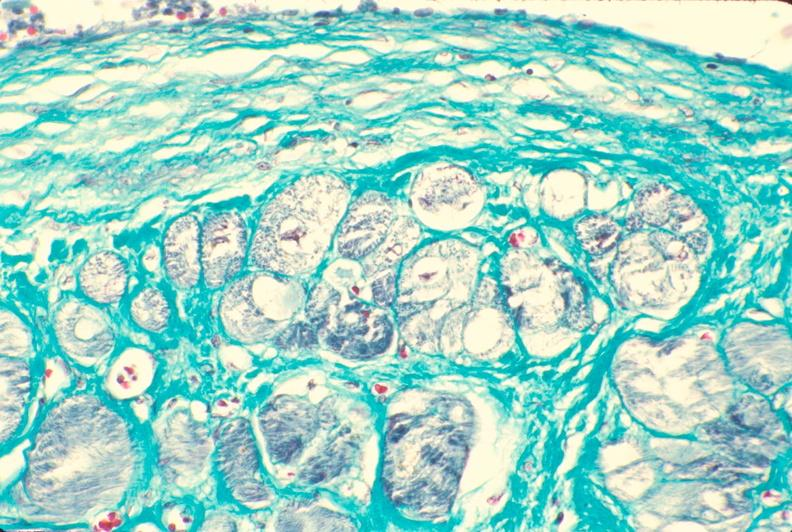does intraductal papillomatosis with apocrine metaplasia show heart, subendocardial vacuolation, chronic ischemic heart disease?
Answer the question using a single word or phrase. No 